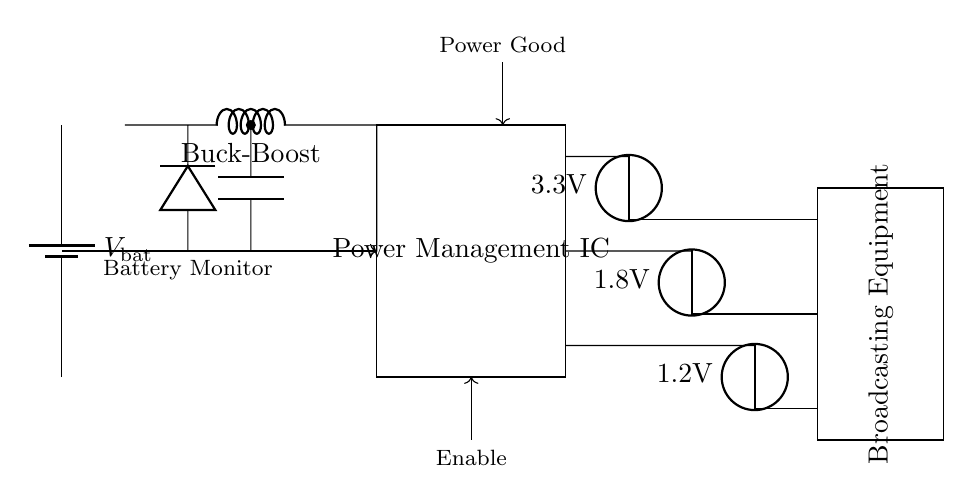What type of component is used for voltage regulation? The circuit includes three voltage regulators labeled as 3.3V, 1.8V, and 1.2V, indicating that they are for regulating output voltages for various outputs in the circuit.
Answer: Voltage regulator What is the primary function of the Buck-Boost converter in this circuit? The Buck-Boost converter adjusts the voltage when the input voltage fluctuates above or below the desired output level, ensuring consistent power delivery to the load.
Answer: Voltage adjustment What voltage does the power management IC provide? The power management IC does not explicitly display a voltage output, but it facilitates the regulation and distribution of power to different components such as the three voltage regulators.
Answer: Multiple voltages How does the circuit ensure battery monitoring? The circuit has a connection labeled as the Battery Monitor, which is represented with a line leading from the battery to the power management IC, allowing the IC to track battery status and control power usage effectively.
Answer: Battery Monitor Which component is associated with ensuring power availability to the broadcasting equipment? The "Power Good" indicator shows that the circuit includes a signal that ensures the output is within specified limits for the broadcasting equipment to operate correctly.
Answer: Power Good What is the main purpose of the Enable signal in the circuit? The Enable signal controls the operational state of the power management IC; when activated, it allows the IC to manage the output voltages to the load effectively.
Answer: Control power What is the load being powered in this circuit? The load is represented by a rectangle labeled as "Broadcasting Equipment," indicating that this is the device being supplied power by the circuit.
Answer: Broadcasting Equipment 